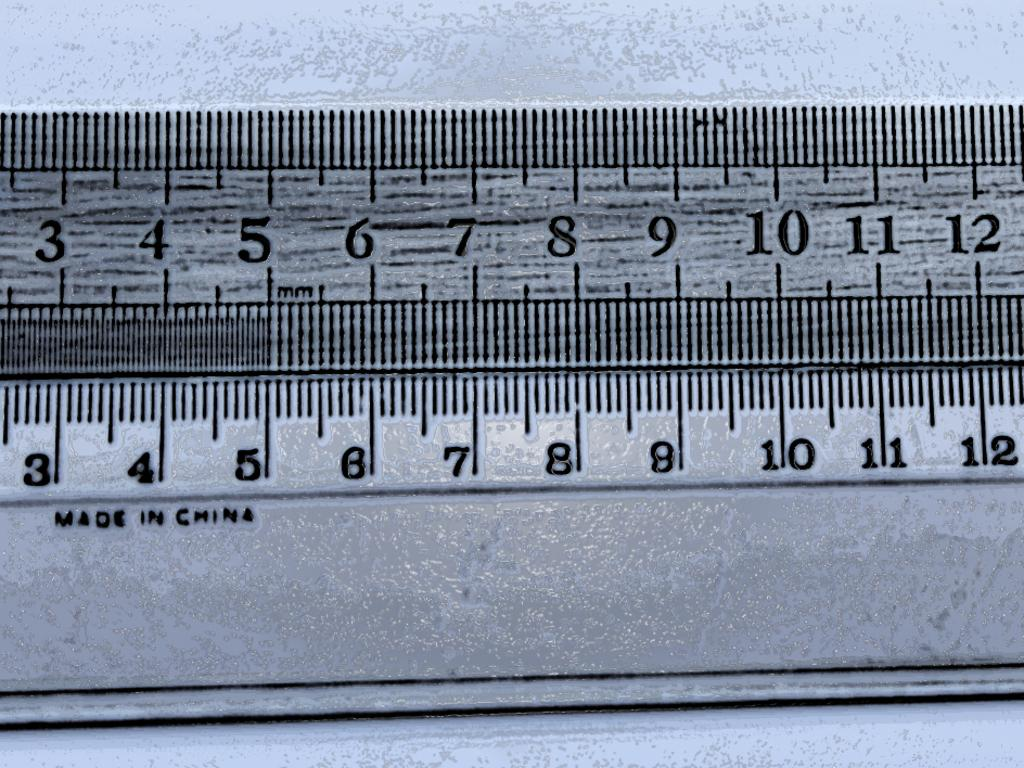Provide a one-sentence caption for the provided image. A ruler showing from number 3 to 12 has been made in china. 